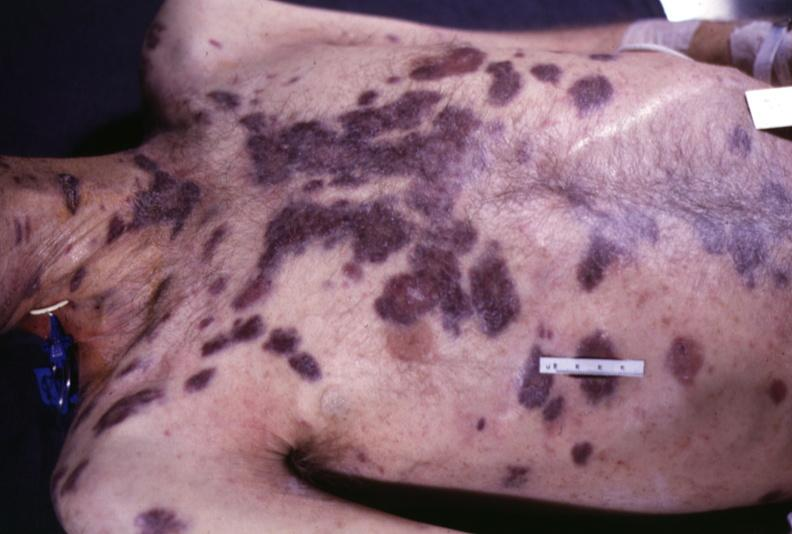does this image show skin, kaposi 's sarcoma?
Answer the question using a single word or phrase. Yes 